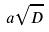<formula> <loc_0><loc_0><loc_500><loc_500>a \sqrt { D }</formula> 